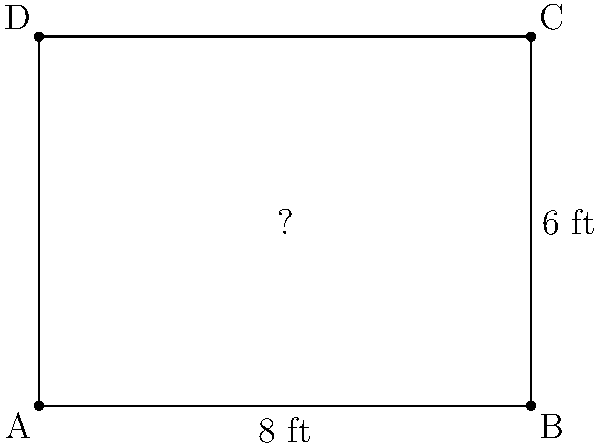You want to set up a green screen in your home studio. The wall you plan to use is rectangular and measures 8 feet wide by 6 feet high. To ensure optimal lighting and framing, you decide to leave a 6-inch border around all sides of the green screen. What should be the dimensions of the green screen to fit within this space while maintaining the same aspect ratio as the wall? Let's approach this step-by-step:

1) First, calculate the usable area after accounting for the 6-inch border:
   Width: $8 \text{ ft} - (2 \times 0.5 \text{ ft}) = 7 \text{ ft}$
   Height: $6 \text{ ft} - (2 \times 0.5 \text{ ft}) = 5 \text{ ft}$

2) The aspect ratio of the wall is $8:6$, which simplifies to $4:3$.

3) To maintain this aspect ratio, let the width of the green screen be $4x$ and the height be $3x$, where $x$ is some factor.

4) We know that the width should be 7 ft:
   $4x = 7 \text{ ft}$
   $x = 1.75 \text{ ft}$

5) Now we can calculate the height:
   Height $= 3x = 3 \times 1.75 \text{ ft} = 5.25 \text{ ft}$

6) However, we need to check if this height fits within our 5 ft limit:
   $5.25 \text{ ft} > 5 \text{ ft}$

7) Since it doesn't fit, we need to adjust. Let's use the height constraint:
   $3x = 5 \text{ ft}$
   $x = \frac{5}{3} \text{ ft} \approx 1.67 \text{ ft}$

8) Now we can calculate the final dimensions:
   Width $= 4x = 4 \times \frac{5}{3} \text{ ft} = \frac{20}{3} \text{ ft} \approx 6.67 \text{ ft}$
   Height $= 3x = 3 \times \frac{5}{3} \text{ ft} = 5 \text{ ft}$

Therefore, the dimensions of the green screen should be approximately 6.67 ft wide by 5 ft high.
Answer: $\frac{20}{3} \text{ ft} \times 5 \text{ ft}$ (or approximately $6.67 \text{ ft} \times 5 \text{ ft}$) 